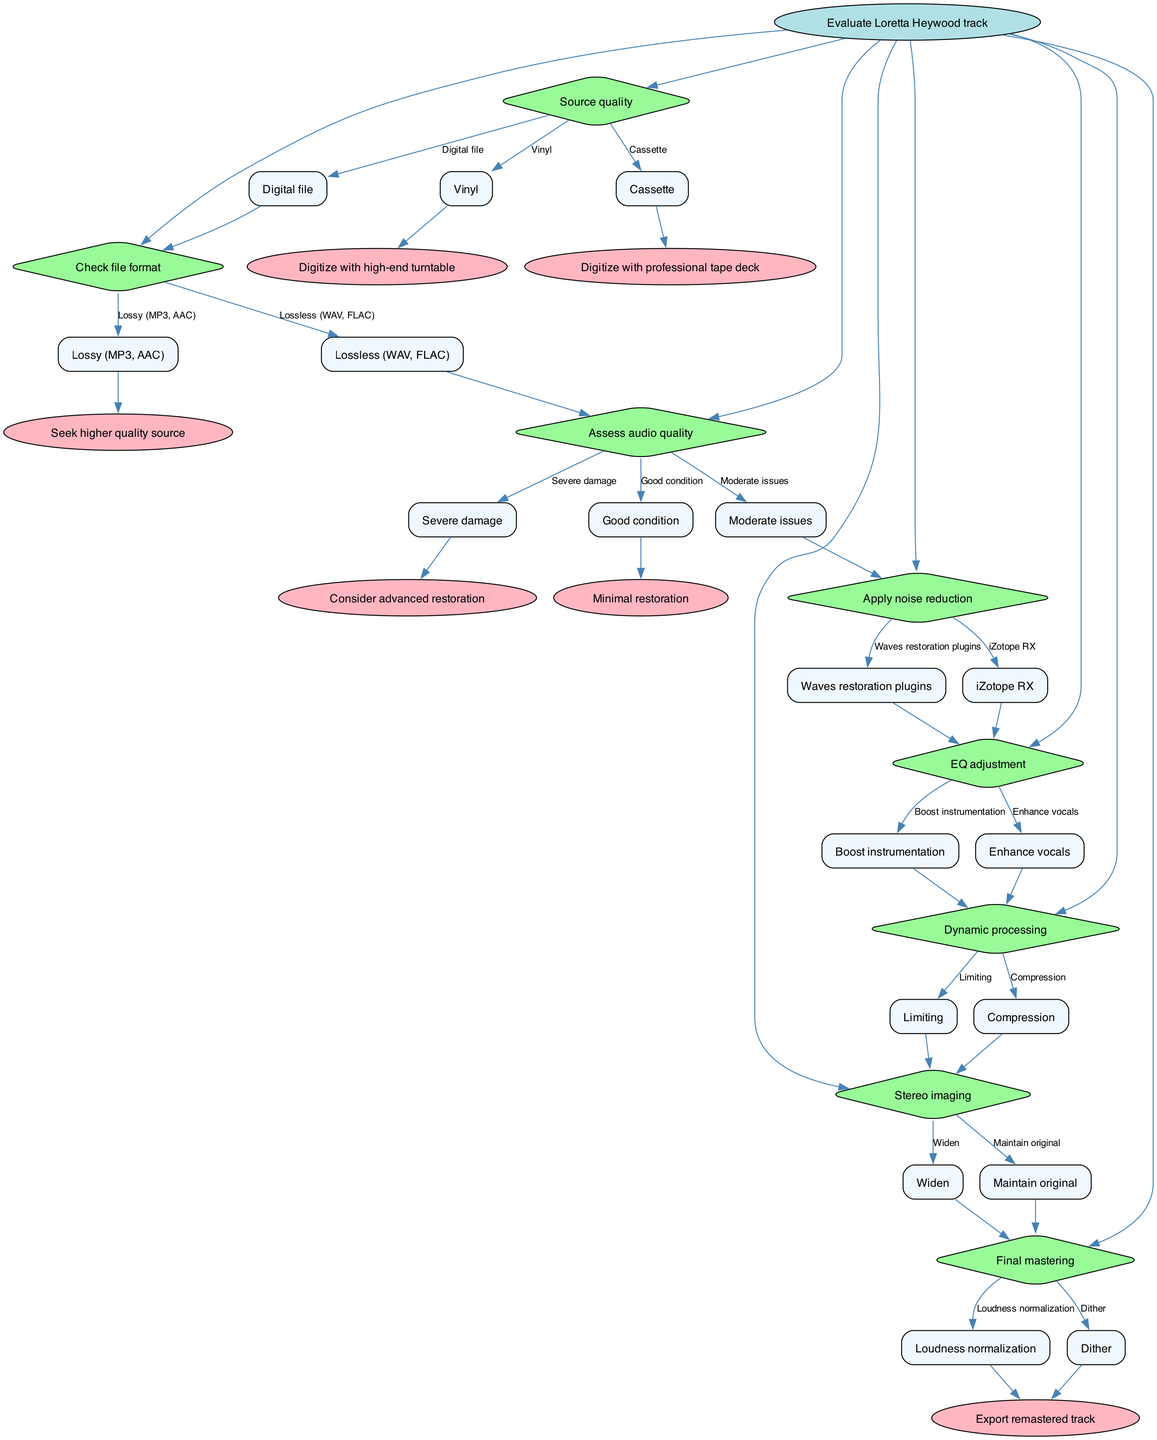What is the first step in the workflow? The diagram indicates that the first step is to "Evaluate Loretta Heywood track," which is the root node of the decision tree.
Answer: Evaluate Loretta Heywood track How many decisions are there in the workflow? The diagram shows a total of seven decisions (nodes), each representing a different step in the workflow process.
Answer: 7 What type of source requires digitization with a high-end turntable? The decision tree specifies that a "Vinyl" source requires digitization with a high-end turntable as per the first choice under "Source quality."
Answer: Vinyl What happens after assessing audio quality if the condition is severe damage? If the audio quality is assessed and found to have severe damage, the next step indicated is to "Consider advanced restoration."
Answer: Consider advanced restoration Which option leads to EQ adjustment after applying noise reduction? The workflow shows that both iZotope RX and Waves restoration plugins lead to the next step of "EQ adjustment" after applying noise reduction.
Answer: EQ adjustment What is the result of stereo imaging if the choice is to widen? The decision tree indicates that whether the choice is to widen or maintain original in the stereo imaging step, the next step is "Final mastering."
Answer: Final mastering What type of processing follows EQ adjustment? The decision tree specifies that after EQ adjustment, the next step is "Dynamic processing."
Answer: Dynamic processing What happens after final mastering if the option is loudness normalization? According to the diagram, after selecting loudness normalization in the final mastering step, the next action is to "Export remastered track."
Answer: Export remastered track Which node represents checking the file format? The diagram identifies that the node "Check file format" is dedicated to evaluating the format of the digital file.
Answer: Check file format 